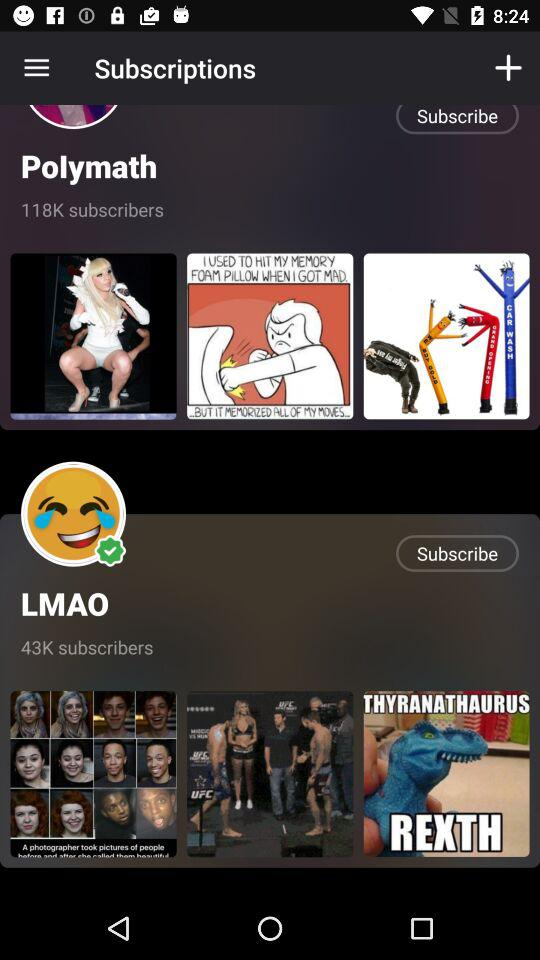How many subscribers does the channel with the purple and white circle have?
Answer the question using a single word or phrase. 118K 